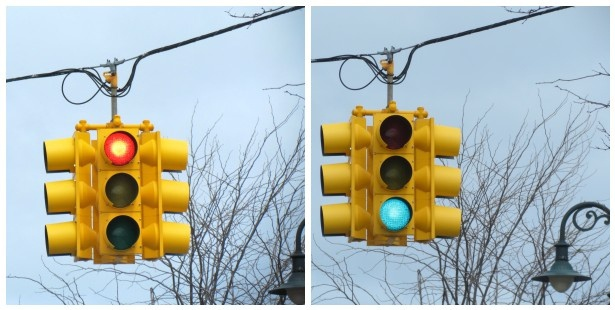Describe the objects in this image and their specific colors. I can see traffic light in white, olive, orange, and black tones, traffic light in white, olive, and black tones, traffic light in white, orange, olive, and gold tones, traffic light in white, orange, olive, and gold tones, and traffic light in white, orange, olive, and gold tones in this image. 